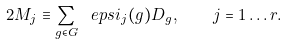<formula> <loc_0><loc_0><loc_500><loc_500>2 M _ { j } \equiv \sum _ { g \in G } \ e p s i _ { j } ( g ) D _ { g } , \quad j = 1 \dots r .</formula> 